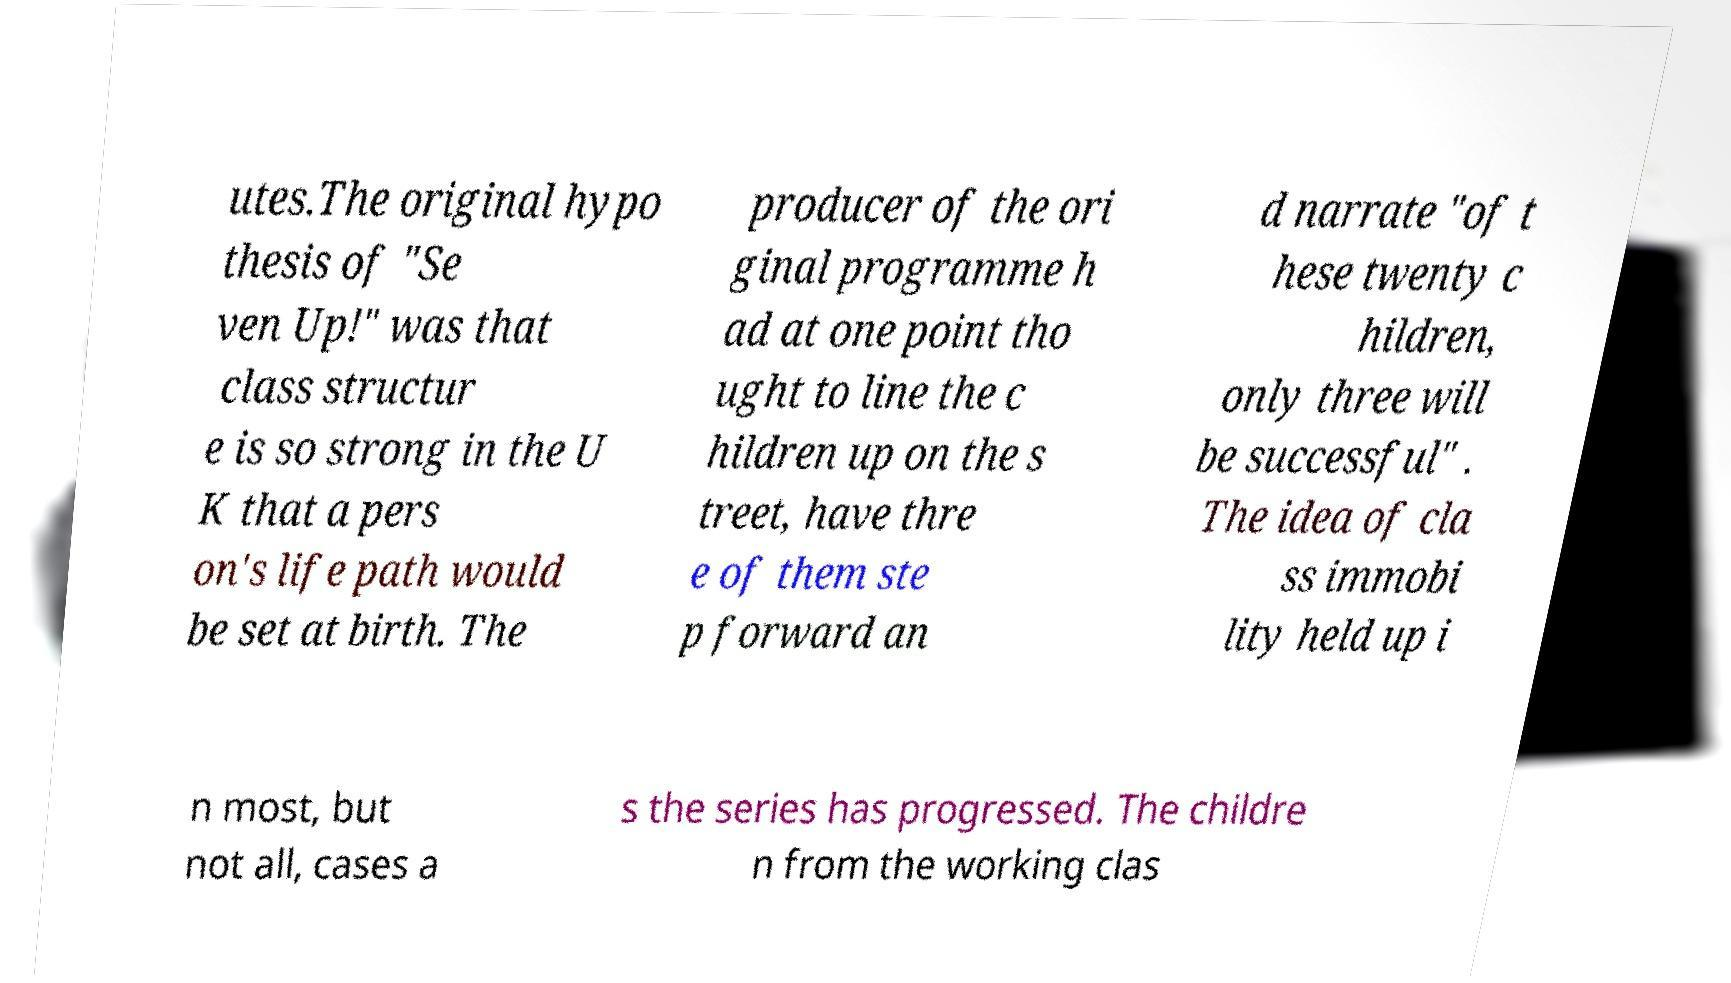Please read and relay the text visible in this image. What does it say? utes.The original hypo thesis of "Se ven Up!" was that class structur e is so strong in the U K that a pers on's life path would be set at birth. The producer of the ori ginal programme h ad at one point tho ught to line the c hildren up on the s treet, have thre e of them ste p forward an d narrate "of t hese twenty c hildren, only three will be successful" . The idea of cla ss immobi lity held up i n most, but not all, cases a s the series has progressed. The childre n from the working clas 